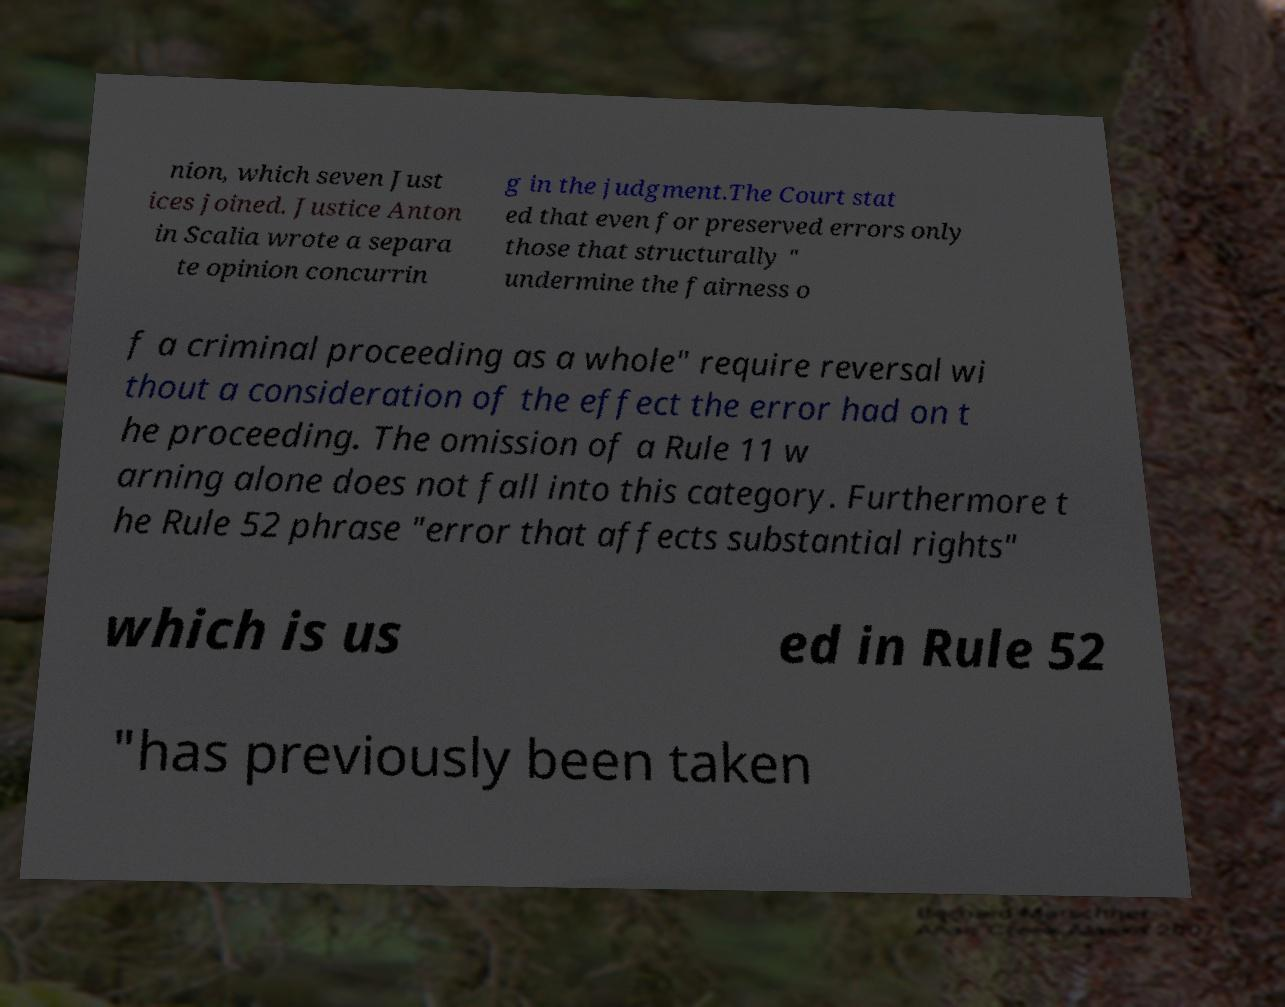Could you assist in decoding the text presented in this image and type it out clearly? nion, which seven Just ices joined. Justice Anton in Scalia wrote a separa te opinion concurrin g in the judgment.The Court stat ed that even for preserved errors only those that structurally " undermine the fairness o f a criminal proceeding as a whole" require reversal wi thout a consideration of the effect the error had on t he proceeding. The omission of a Rule 11 w arning alone does not fall into this category. Furthermore t he Rule 52 phrase "error that affects substantial rights" which is us ed in Rule 52 "has previously been taken 